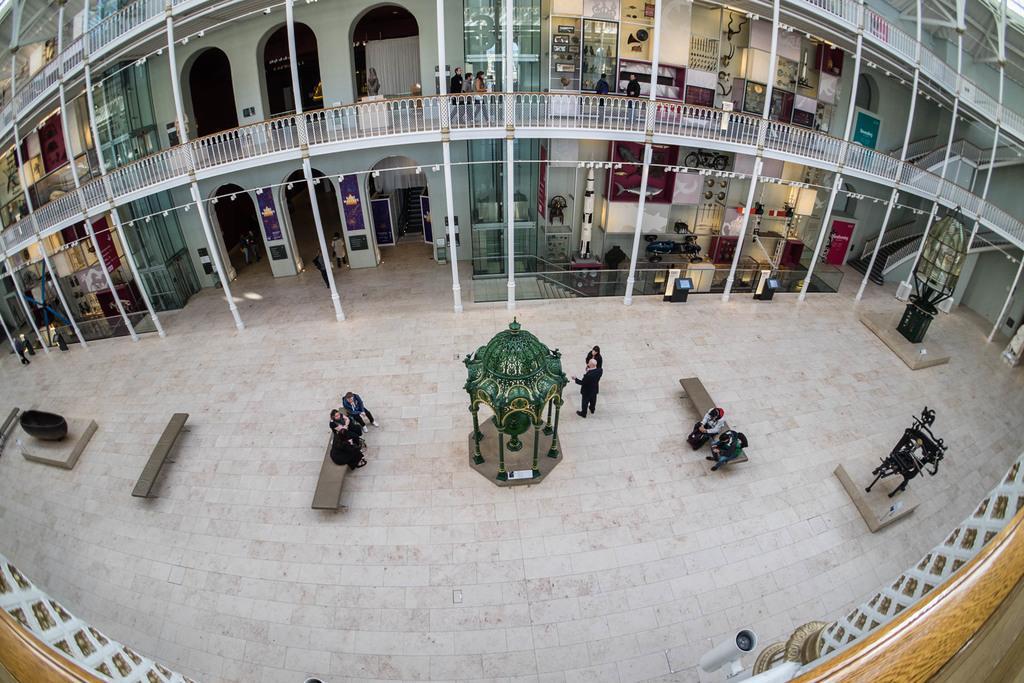Can you describe this image briefly? In this picture we can see an inside view of a building, here we can see people on the ground and we can see benches, poles and some objects. 